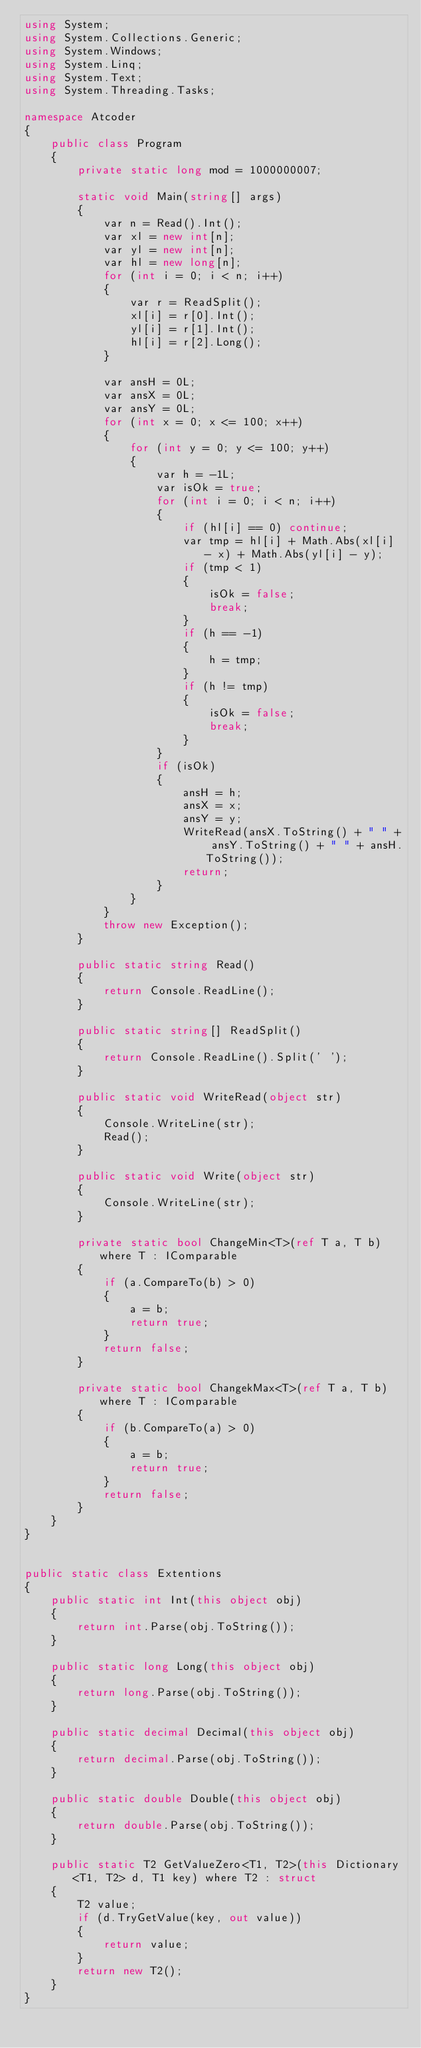<code> <loc_0><loc_0><loc_500><loc_500><_C#_>using System;
using System.Collections.Generic;
using System.Windows;
using System.Linq;
using System.Text;
using System.Threading.Tasks;

namespace Atcoder
{
    public class Program
    {
        private static long mod = 1000000007;

        static void Main(string[] args)
        {
            var n = Read().Int();
            var xl = new int[n];
            var yl = new int[n];
            var hl = new long[n];
            for (int i = 0; i < n; i++)
            {
                var r = ReadSplit();
                xl[i] = r[0].Int();
                yl[i] = r[1].Int();
                hl[i] = r[2].Long();
            }

            var ansH = 0L;
            var ansX = 0L;
            var ansY = 0L;
            for (int x = 0; x <= 100; x++)
            {
                for (int y = 0; y <= 100; y++)
                {
                    var h = -1L;
                    var isOk = true;
                    for (int i = 0; i < n; i++)
                    {
                        if (hl[i] == 0) continue;
                        var tmp = hl[i] + Math.Abs(xl[i] - x) + Math.Abs(yl[i] - y);
                        if (tmp < 1)
                        {
                            isOk = false;
                            break;
                        }
                        if (h == -1)
                        {
                            h = tmp;
                        }
                        if (h != tmp)
                        {
                            isOk = false;
                            break;
                        }
                    }
                    if (isOk)
                    {
                        ansH = h;
                        ansX = x;
                        ansY = y;
                        WriteRead(ansX.ToString() + " " + ansY.ToString() + " " + ansH.ToString());
                        return;
                    }
                }
            }
            throw new Exception();
        }

        public static string Read()
        {
            return Console.ReadLine();
        }

        public static string[] ReadSplit()
        {
            return Console.ReadLine().Split(' ');
        }

        public static void WriteRead(object str)
        {
            Console.WriteLine(str);
            Read();
        }

        public static void Write(object str)
        {
            Console.WriteLine(str);
        }

        private static bool ChangeMin<T>(ref T a, T b) where T : IComparable
        {
            if (a.CompareTo(b) > 0)
            {
                a = b;
                return true;
            }
            return false;
        }

        private static bool ChangekMax<T>(ref T a, T b) where T : IComparable
        {
            if (b.CompareTo(a) > 0)
            {
                a = b;
                return true;
            }
            return false;
        }
    }
}


public static class Extentions
{
    public static int Int(this object obj)
    {
        return int.Parse(obj.ToString());
    }

    public static long Long(this object obj)
    {
        return long.Parse(obj.ToString());
    }

    public static decimal Decimal(this object obj)
    {
        return decimal.Parse(obj.ToString());
    }

    public static double Double(this object obj)
    {
        return double.Parse(obj.ToString());
    }

    public static T2 GetValueZero<T1, T2>(this Dictionary<T1, T2> d, T1 key) where T2 : struct
    {
        T2 value;
        if (d.TryGetValue(key, out value))
        {
            return value;
        }
        return new T2();
    }
}

</code> 